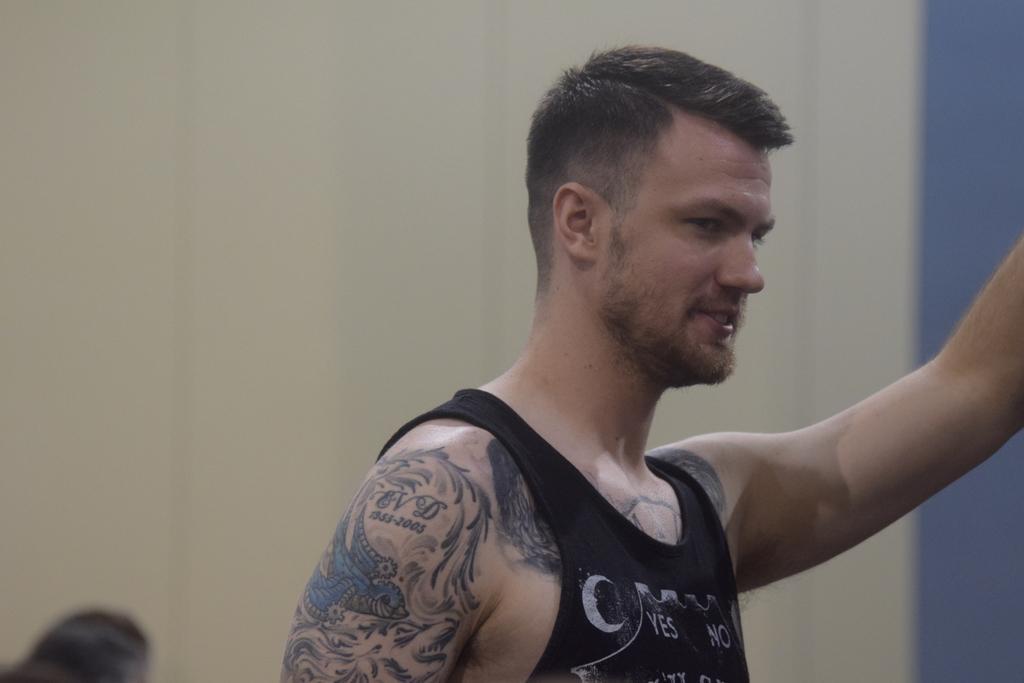Could you give a brief overview of what you see in this image? In this image we can see a person wearing a dress. In the background, we can see the wall. 